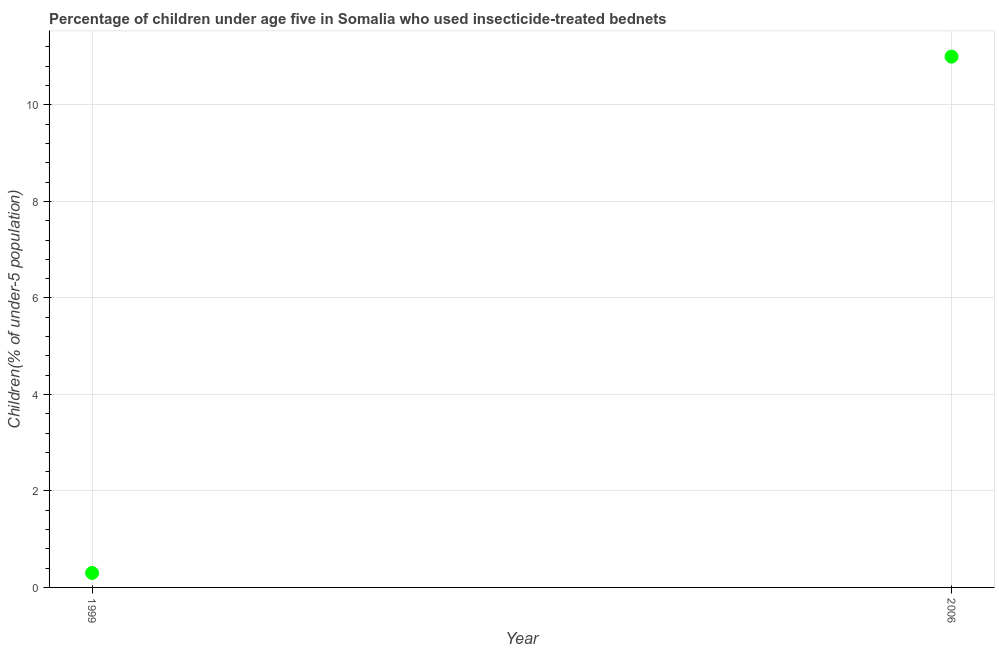What is the percentage of children who use of insecticide-treated bed nets in 1999?
Your response must be concise. 0.3. Across all years, what is the maximum percentage of children who use of insecticide-treated bed nets?
Make the answer very short. 11. Across all years, what is the minimum percentage of children who use of insecticide-treated bed nets?
Provide a short and direct response. 0.3. In which year was the percentage of children who use of insecticide-treated bed nets maximum?
Ensure brevity in your answer.  2006. In which year was the percentage of children who use of insecticide-treated bed nets minimum?
Your response must be concise. 1999. What is the sum of the percentage of children who use of insecticide-treated bed nets?
Your answer should be very brief. 11.3. What is the difference between the percentage of children who use of insecticide-treated bed nets in 1999 and 2006?
Your response must be concise. -10.7. What is the average percentage of children who use of insecticide-treated bed nets per year?
Your response must be concise. 5.65. What is the median percentage of children who use of insecticide-treated bed nets?
Ensure brevity in your answer.  5.65. Do a majority of the years between 2006 and 1999 (inclusive) have percentage of children who use of insecticide-treated bed nets greater than 2.8 %?
Offer a terse response. No. What is the ratio of the percentage of children who use of insecticide-treated bed nets in 1999 to that in 2006?
Your answer should be very brief. 0.03. In how many years, is the percentage of children who use of insecticide-treated bed nets greater than the average percentage of children who use of insecticide-treated bed nets taken over all years?
Make the answer very short. 1. How many years are there in the graph?
Offer a very short reply. 2. Are the values on the major ticks of Y-axis written in scientific E-notation?
Provide a succinct answer. No. Does the graph contain grids?
Give a very brief answer. Yes. What is the title of the graph?
Your answer should be compact. Percentage of children under age five in Somalia who used insecticide-treated bednets. What is the label or title of the X-axis?
Offer a very short reply. Year. What is the label or title of the Y-axis?
Keep it short and to the point. Children(% of under-5 population). What is the Children(% of under-5 population) in 1999?
Provide a succinct answer. 0.3. What is the difference between the Children(% of under-5 population) in 1999 and 2006?
Provide a short and direct response. -10.7. What is the ratio of the Children(% of under-5 population) in 1999 to that in 2006?
Offer a terse response. 0.03. 